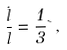<formula> <loc_0><loc_0><loc_500><loc_500>\frac { \dot { l } } { l } = \frac { 1 } { 3 } \theta \, ,</formula> 